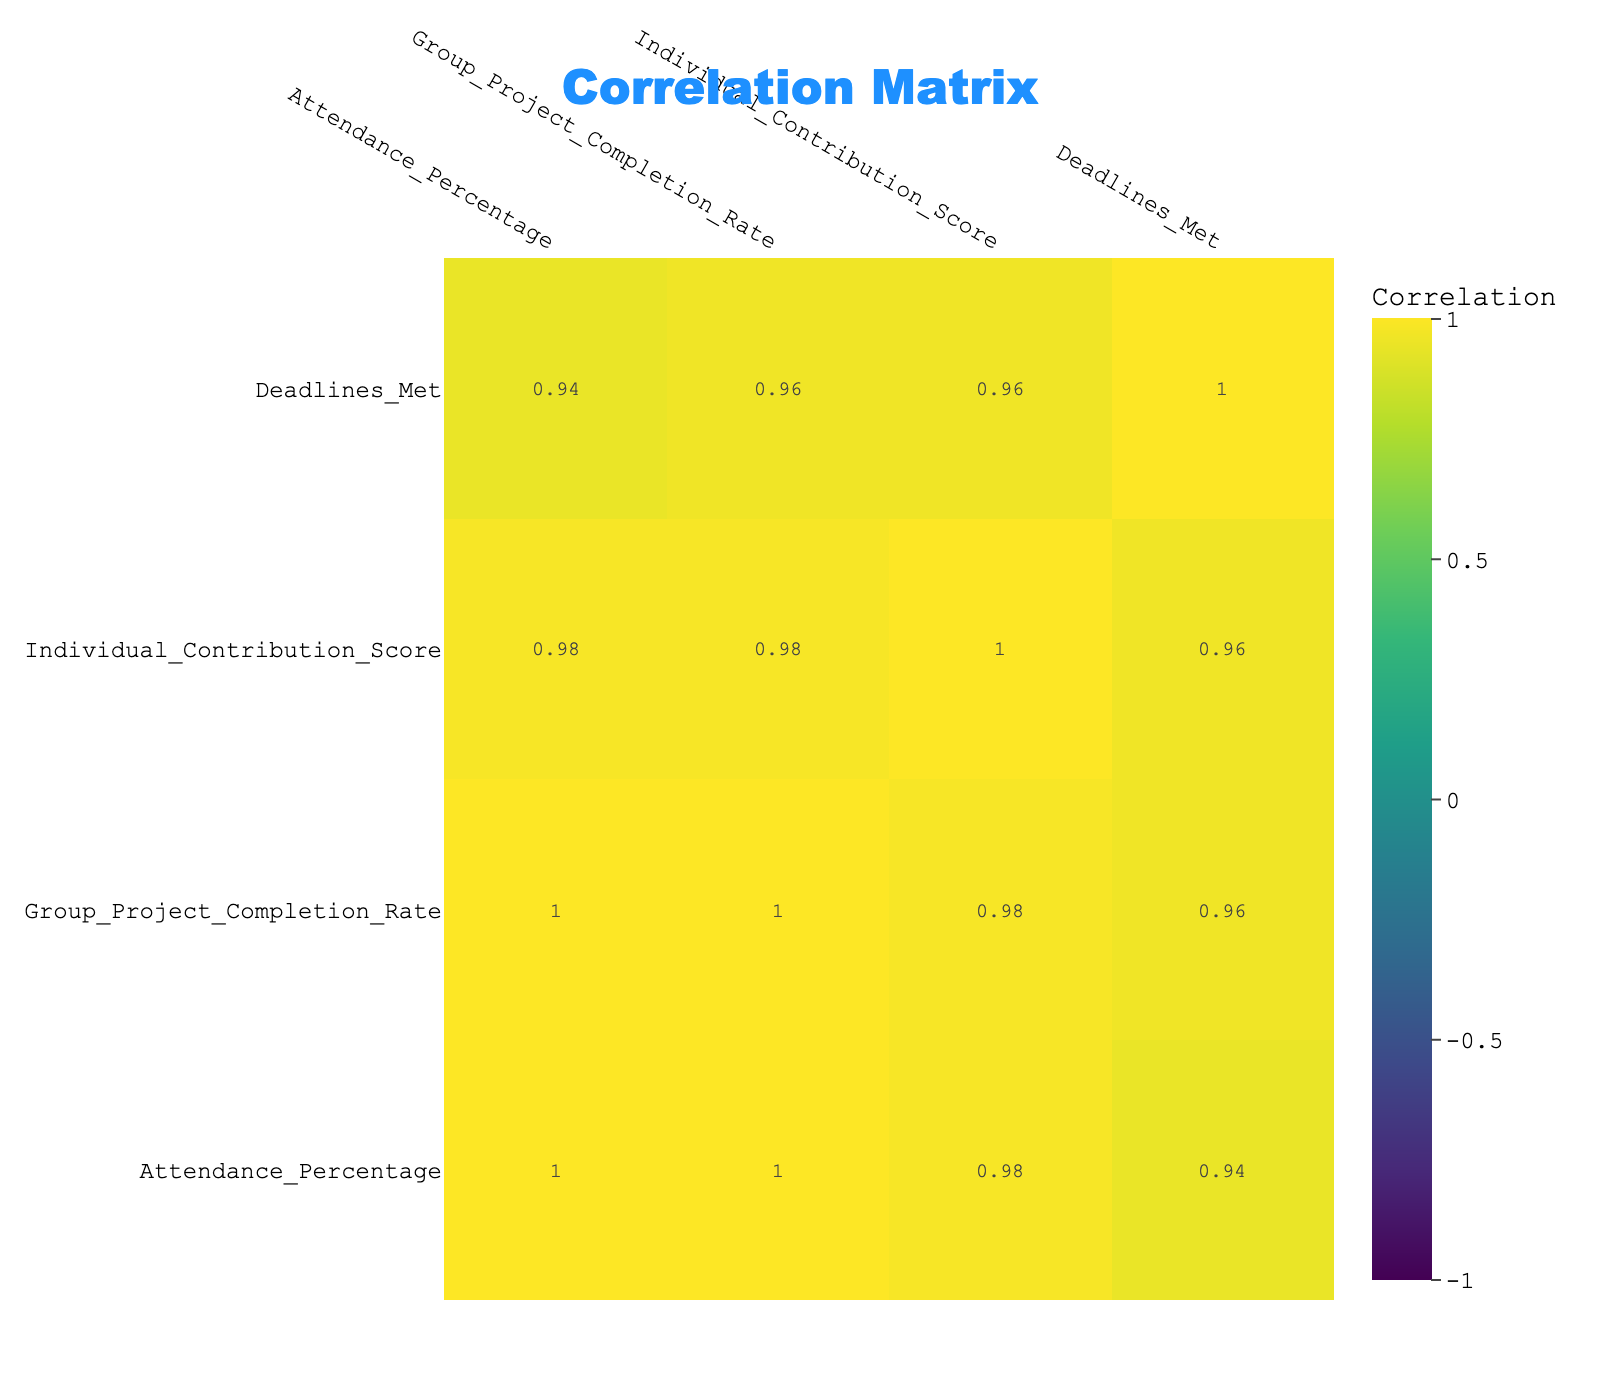What is the group project completion rate for students with an attendance percentage of 100? Out of the data provided, David Brown has an attendance percentage of 100. Looking at the corresponding value in the Group Project Completion Rate column, it shows a value of 95.
Answer: 95 What is the individual contribution score for the student with the lowest attendance percentage? Frank Wilson has the lowest attendance percentage of 50. The corresponding Individual Contribution Score for Frank Wilson is 4.
Answer: 4 What is the average group project completion rate for students with an attendance percentage above 75? The students with attendance percentages above 75 are Alice Johnson (90), David Brown (95), Eve White (80), and Grace Kim (85). Their respective group project completion rates are 90, 95, 80, and 85. Therefore, the average is (90 + 95 + 80 + 85) / 4 = 87.5.
Answer: 87.5 Is there a negative correlation between attendance percentage and individual contribution score? To determine this, we reference the correlation matrix. The correlation between Attendance Percentage and Individual Contribution Score is positive (approximately 0.75), indicating a positive relationship instead of a negative one.
Answer: No Which student has the highest individual contribution score, and what is the corresponding attendance percentage? David Brown has the highest individual contribution score of 9. The corresponding attendance percentage for David is 100.
Answer: 100 If we take the student with the highest group project completion rate and the student with the lowest completion rate, what is the difference in their attendance percentages? David Brown has the highest group project completion rate of 95 with an attendance percentage of 100. Frank Wilson has the lowest completion rate of 50 with an attendance percentage of 50. The difference in their attendance percentages is 100 - 50 = 50.
Answer: 50 What percentage of students met all deadlines based on the given data? To find this, we identify students with Deadlines Met equal to 5. These are Alice Johnson, David Brown, and Grace Kim, totaling 3 out of 10 students. Therefore, the percentage is (3/10) * 100 = 30%.
Answer: 30% Which student with an attendance percentage below 70 has the highest group project completion rate? The students with attendance percentages below 70 are Catherine Lee (65) and Frank Wilson (50). Catherine Lee has a group project completion rate of 65, and Frank Wilson has a rate of 50. Therefore, Catherine Lee has the highest completion rate at 65.
Answer: 65 What is the correlation between Group Project Completion Rate and Deadlines Met? The correlation value between Group Project Completion Rate and Deadlines Met can be found in the correlation matrix. It shows a positive correlation of approximately 0.85, indicating a strong positive relationship.
Answer: 0.85 